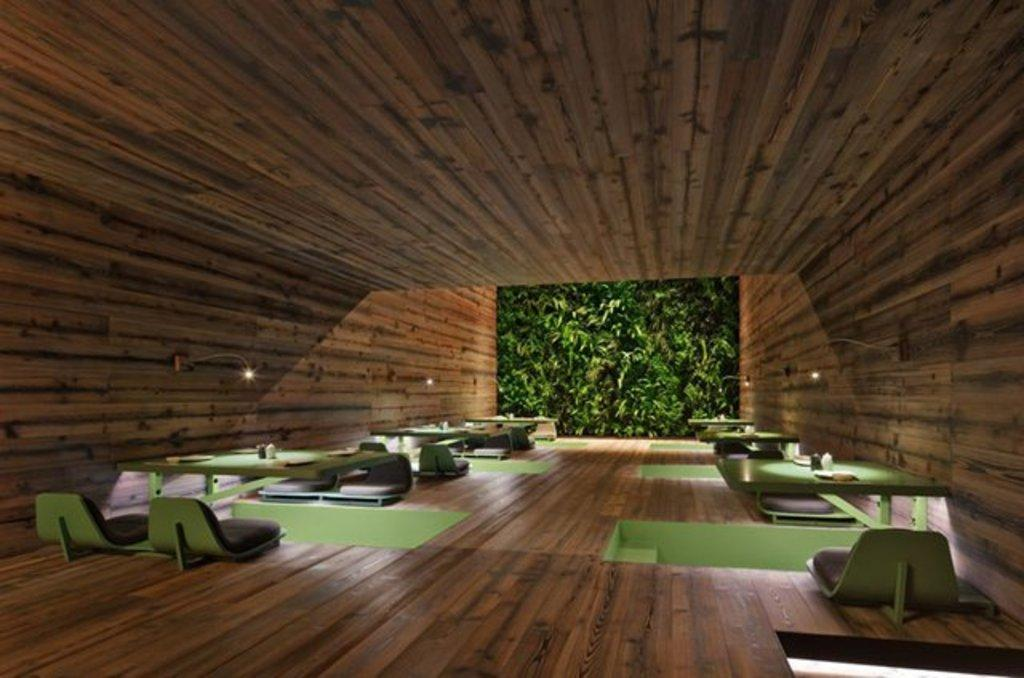What type of furniture is present in the image? There are tables and chairs in the image. What is covering the area above the tables and chairs? There is a roof visible in the image. Where are the lights located in the image? The lights are attached to the wall on the left side of the image. What can be seen in the center of the image? There is a screen in the center of the image. What type of engine is powering the tables and chairs in the image? There is no engine present in the image, as tables and chairs are not powered by engines. 